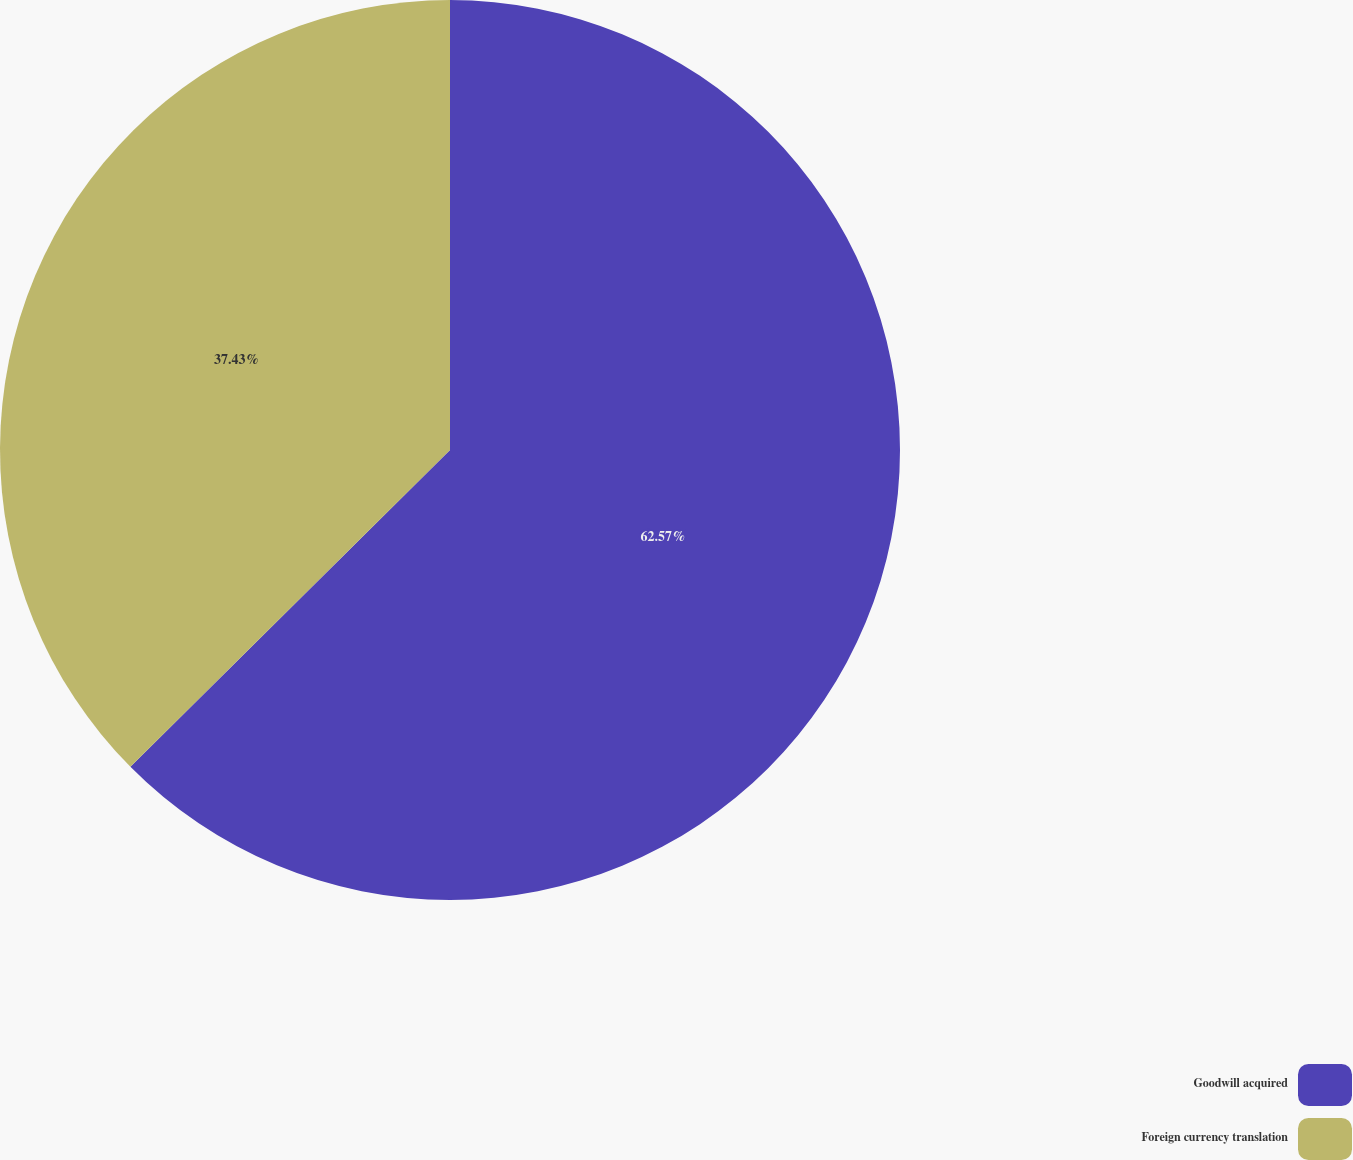Convert chart to OTSL. <chart><loc_0><loc_0><loc_500><loc_500><pie_chart><fcel>Goodwill acquired<fcel>Foreign currency translation<nl><fcel>62.57%<fcel>37.43%<nl></chart> 